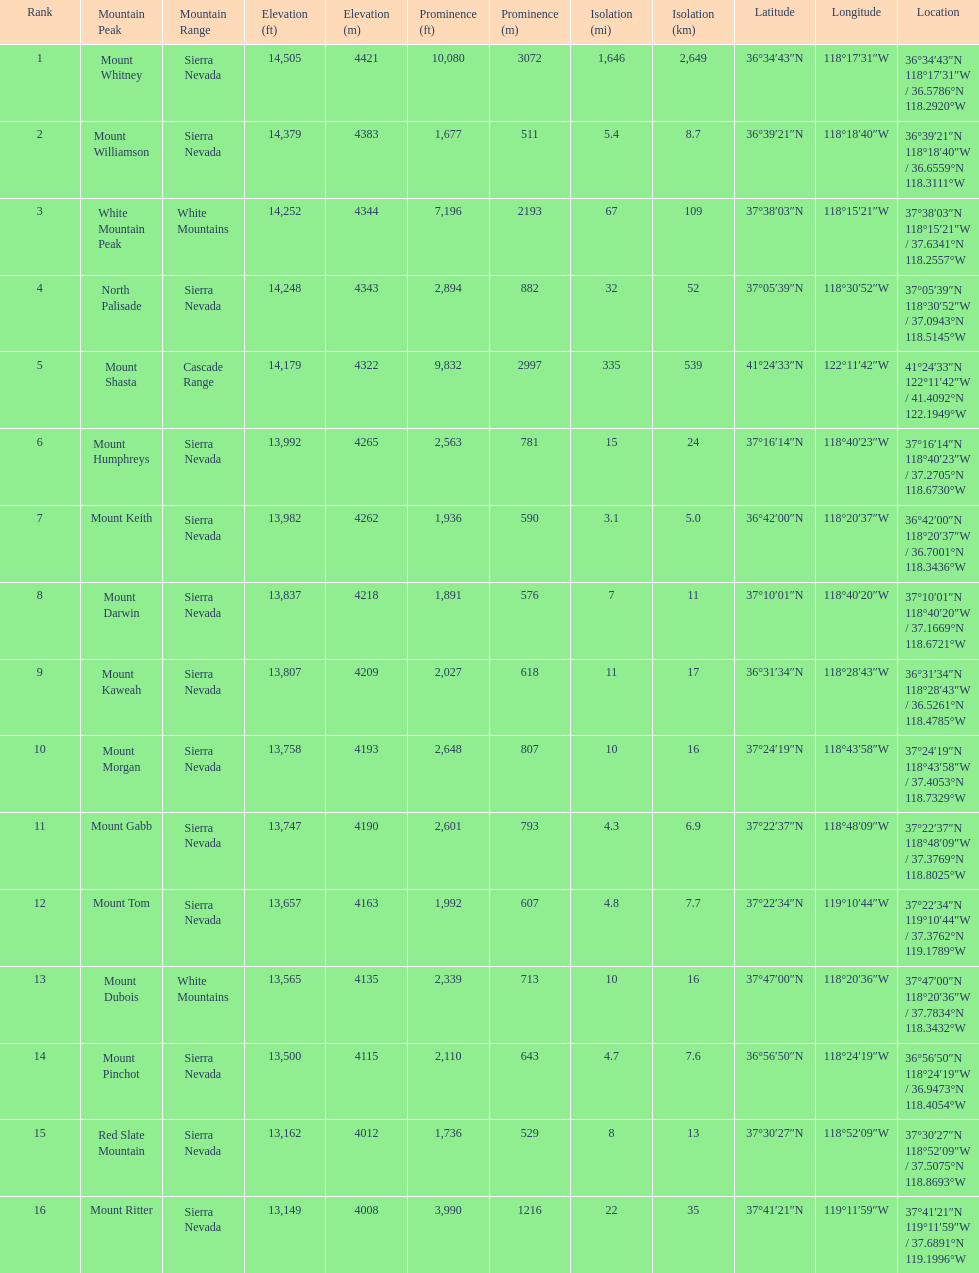Which mountain peak is the only mountain peak in the cascade range? Mount Shasta. 